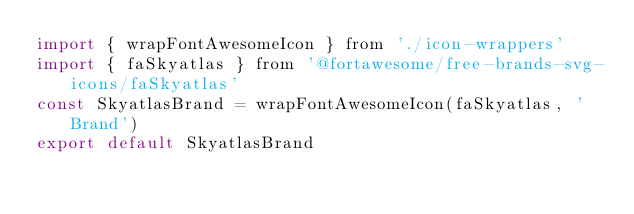Convert code to text. <code><loc_0><loc_0><loc_500><loc_500><_JavaScript_>import { wrapFontAwesomeIcon } from './icon-wrappers'
import { faSkyatlas } from '@fortawesome/free-brands-svg-icons/faSkyatlas'
const SkyatlasBrand = wrapFontAwesomeIcon(faSkyatlas, 'Brand')
export default SkyatlasBrand
</code> 